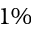<formula> <loc_0><loc_0><loc_500><loc_500>1 \%</formula> 